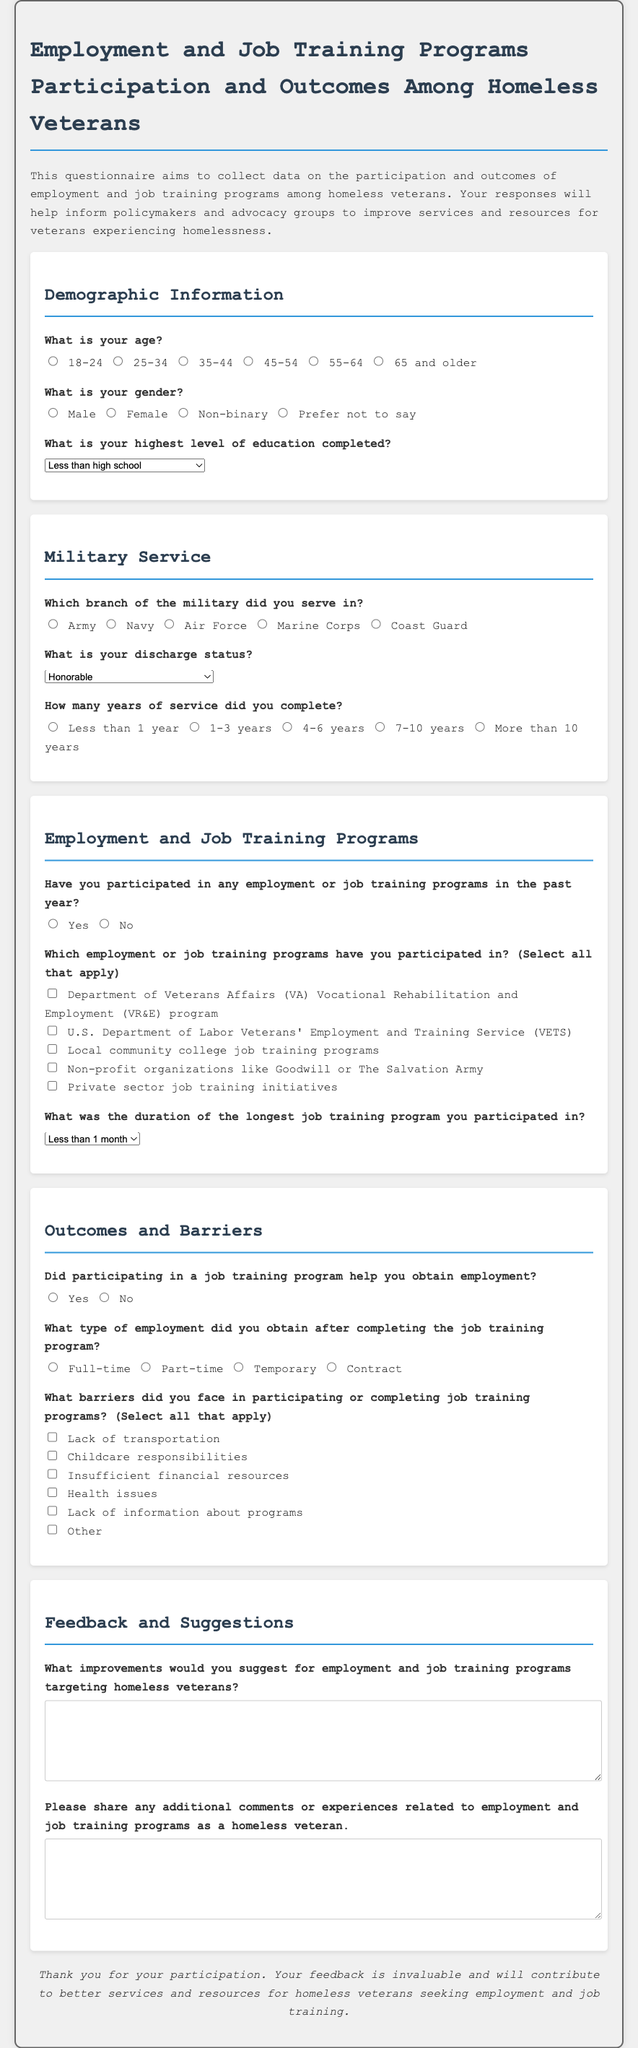What is the title of the questionnaire? The title states the purpose and focus of the document, which is to gather information on employment and job training programs for homeless veterans.
Answer: Employment and Job Training Programs Participation and Outcomes Among Homeless Veterans What is the highest level of education completed that can be selected? The selection list for education includes various options, and the highest option listed is a Doctoral degree.
Answer: Doctoral degree How many years of service is one of the options provided? The questionnaire includes a question about years of service, with options including "Less than 1 year," "1-3 years," etc.
Answer: More than 10 years Did the questionnaire inquire about discharge status? The document features a section specifically addressing military service, including a question on discharge status options.
Answer: Yes What type of employment did the questionnaire ask about obtaining after job training? There's a question regarding the type of employment achieved after completion of job training programs, with options such as full-time and part-time.
Answer: Part-time What is one barrier to participating in job training programs listed in the questionnaire? The document lists potential barriers faced by participants, including lack of transportation and financial issues.
Answer: Lack of transportation Which branch of military service can a participant select? The military service section provides options including various branches such as Army, Navy, and Marine Corps.
Answer: Army What feedback does the questionnaire seek regarding improvements? The feedback section inquires about suggestions for enhancing employment and job training programs targeting homeless veterans.
Answer: Improvements to programs 